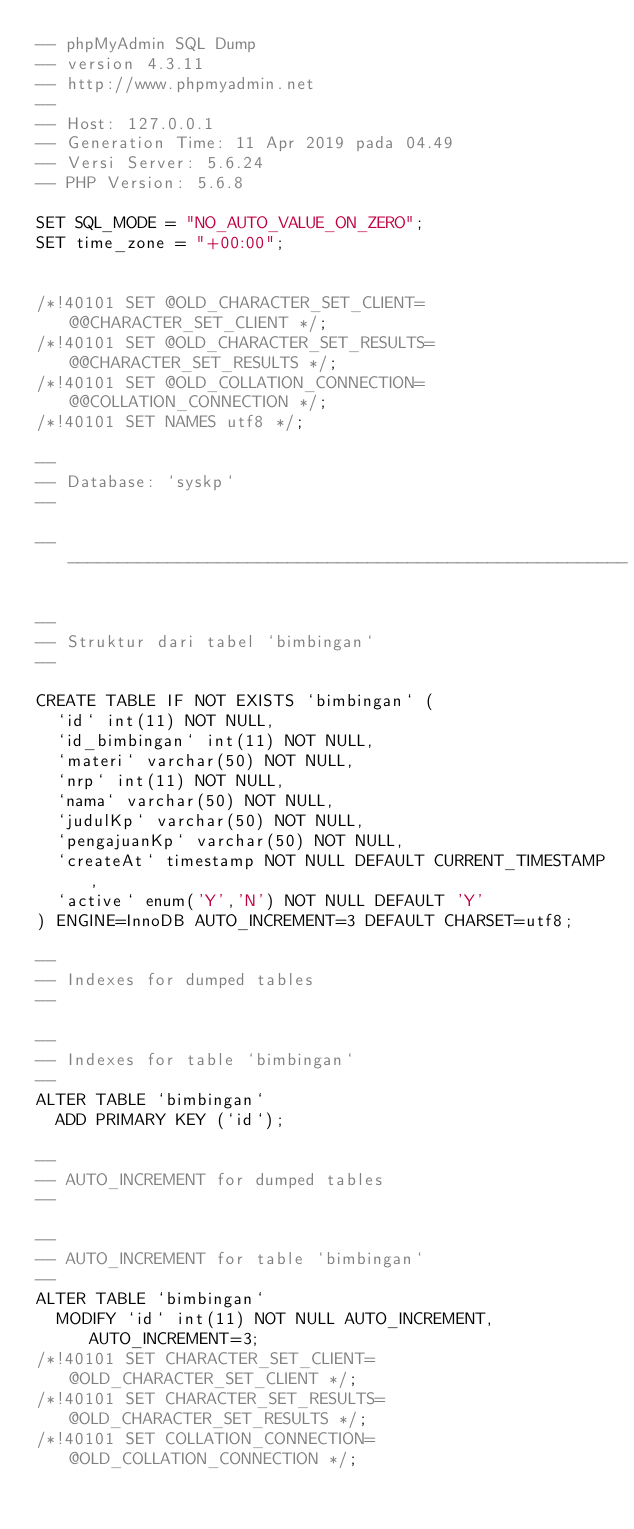Convert code to text. <code><loc_0><loc_0><loc_500><loc_500><_SQL_>-- phpMyAdmin SQL Dump
-- version 4.3.11
-- http://www.phpmyadmin.net
--
-- Host: 127.0.0.1
-- Generation Time: 11 Apr 2019 pada 04.49
-- Versi Server: 5.6.24
-- PHP Version: 5.6.8

SET SQL_MODE = "NO_AUTO_VALUE_ON_ZERO";
SET time_zone = "+00:00";


/*!40101 SET @OLD_CHARACTER_SET_CLIENT=@@CHARACTER_SET_CLIENT */;
/*!40101 SET @OLD_CHARACTER_SET_RESULTS=@@CHARACTER_SET_RESULTS */;
/*!40101 SET @OLD_COLLATION_CONNECTION=@@COLLATION_CONNECTION */;
/*!40101 SET NAMES utf8 */;

--
-- Database: `syskp`
--

-- --------------------------------------------------------

--
-- Struktur dari tabel `bimbingan`
--

CREATE TABLE IF NOT EXISTS `bimbingan` (
  `id` int(11) NOT NULL,
  `id_bimbingan` int(11) NOT NULL,
  `materi` varchar(50) NOT NULL,
  `nrp` int(11) NOT NULL,
  `nama` varchar(50) NOT NULL,
  `judulKp` varchar(50) NOT NULL,
  `pengajuanKp` varchar(50) NOT NULL,
  `createAt` timestamp NOT NULL DEFAULT CURRENT_TIMESTAMP,
  `active` enum('Y','N') NOT NULL DEFAULT 'Y'
) ENGINE=InnoDB AUTO_INCREMENT=3 DEFAULT CHARSET=utf8;

--
-- Indexes for dumped tables
--

--
-- Indexes for table `bimbingan`
--
ALTER TABLE `bimbingan`
  ADD PRIMARY KEY (`id`);

--
-- AUTO_INCREMENT for dumped tables
--

--
-- AUTO_INCREMENT for table `bimbingan`
--
ALTER TABLE `bimbingan`
  MODIFY `id` int(11) NOT NULL AUTO_INCREMENT,AUTO_INCREMENT=3;
/*!40101 SET CHARACTER_SET_CLIENT=@OLD_CHARACTER_SET_CLIENT */;
/*!40101 SET CHARACTER_SET_RESULTS=@OLD_CHARACTER_SET_RESULTS */;
/*!40101 SET COLLATION_CONNECTION=@OLD_COLLATION_CONNECTION */;
</code> 